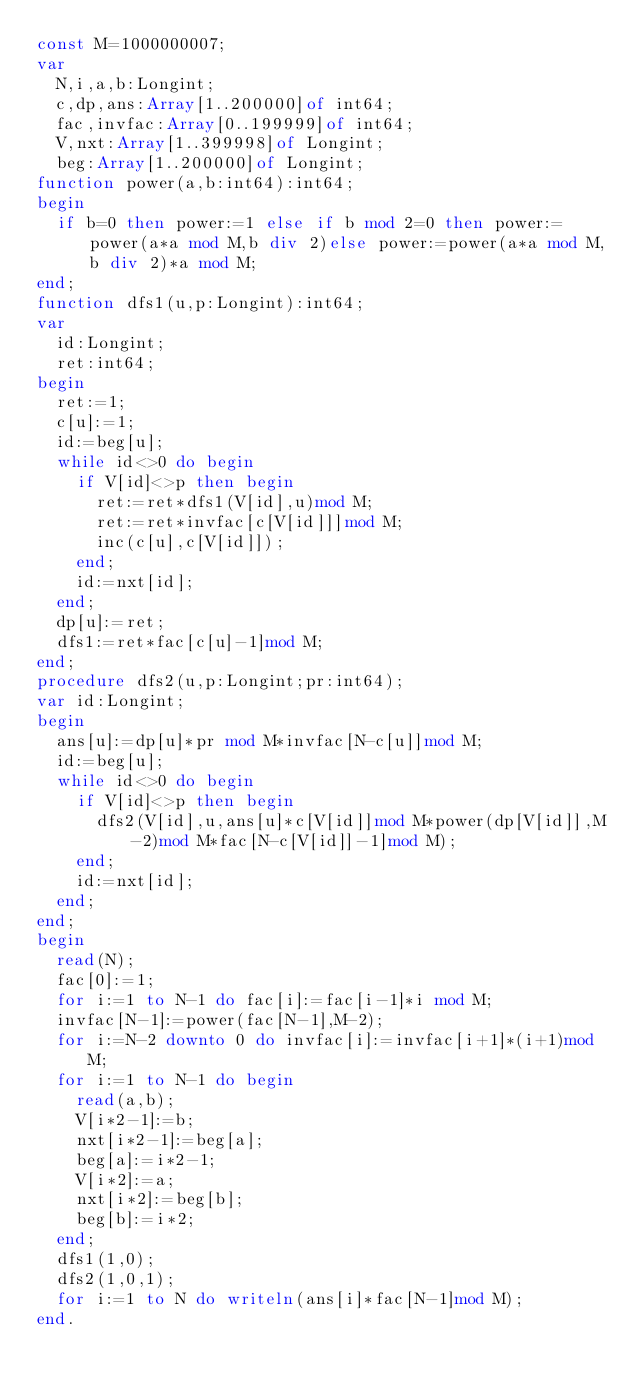<code> <loc_0><loc_0><loc_500><loc_500><_Pascal_>const M=1000000007;
var
	N,i,a,b:Longint;
	c,dp,ans:Array[1..200000]of int64;
	fac,invfac:Array[0..199999]of int64;
	V,nxt:Array[1..399998]of Longint;
	beg:Array[1..200000]of Longint;
function power(a,b:int64):int64;
begin
	if b=0 then power:=1 else if b mod 2=0 then power:=power(a*a mod M,b div 2)else power:=power(a*a mod M,b div 2)*a mod M;
end;
function dfs1(u,p:Longint):int64;
var
	id:Longint;
	ret:int64;
begin
	ret:=1;
	c[u]:=1;
	id:=beg[u];
	while id<>0 do begin
		if V[id]<>p then begin
			ret:=ret*dfs1(V[id],u)mod M;
			ret:=ret*invfac[c[V[id]]]mod M;
			inc(c[u],c[V[id]]);
		end;
		id:=nxt[id];
	end;
	dp[u]:=ret;
	dfs1:=ret*fac[c[u]-1]mod M;
end;
procedure dfs2(u,p:Longint;pr:int64);
var id:Longint;
begin
	ans[u]:=dp[u]*pr mod M*invfac[N-c[u]]mod M;
	id:=beg[u];
	while id<>0 do begin
		if V[id]<>p then begin
			dfs2(V[id],u,ans[u]*c[V[id]]mod M*power(dp[V[id]],M-2)mod M*fac[N-c[V[id]]-1]mod M);
		end;
		id:=nxt[id];
	end;
end;
begin
	read(N);
	fac[0]:=1;
	for i:=1 to N-1 do fac[i]:=fac[i-1]*i mod M;
	invfac[N-1]:=power(fac[N-1],M-2);
	for i:=N-2 downto 0 do invfac[i]:=invfac[i+1]*(i+1)mod M;
	for i:=1 to N-1 do begin
		read(a,b);
		V[i*2-1]:=b;
		nxt[i*2-1]:=beg[a];
		beg[a]:=i*2-1;
		V[i*2]:=a;
		nxt[i*2]:=beg[b];
		beg[b]:=i*2;
	end;
	dfs1(1,0);
	dfs2(1,0,1);
	for i:=1 to N do writeln(ans[i]*fac[N-1]mod M);
end.
</code> 